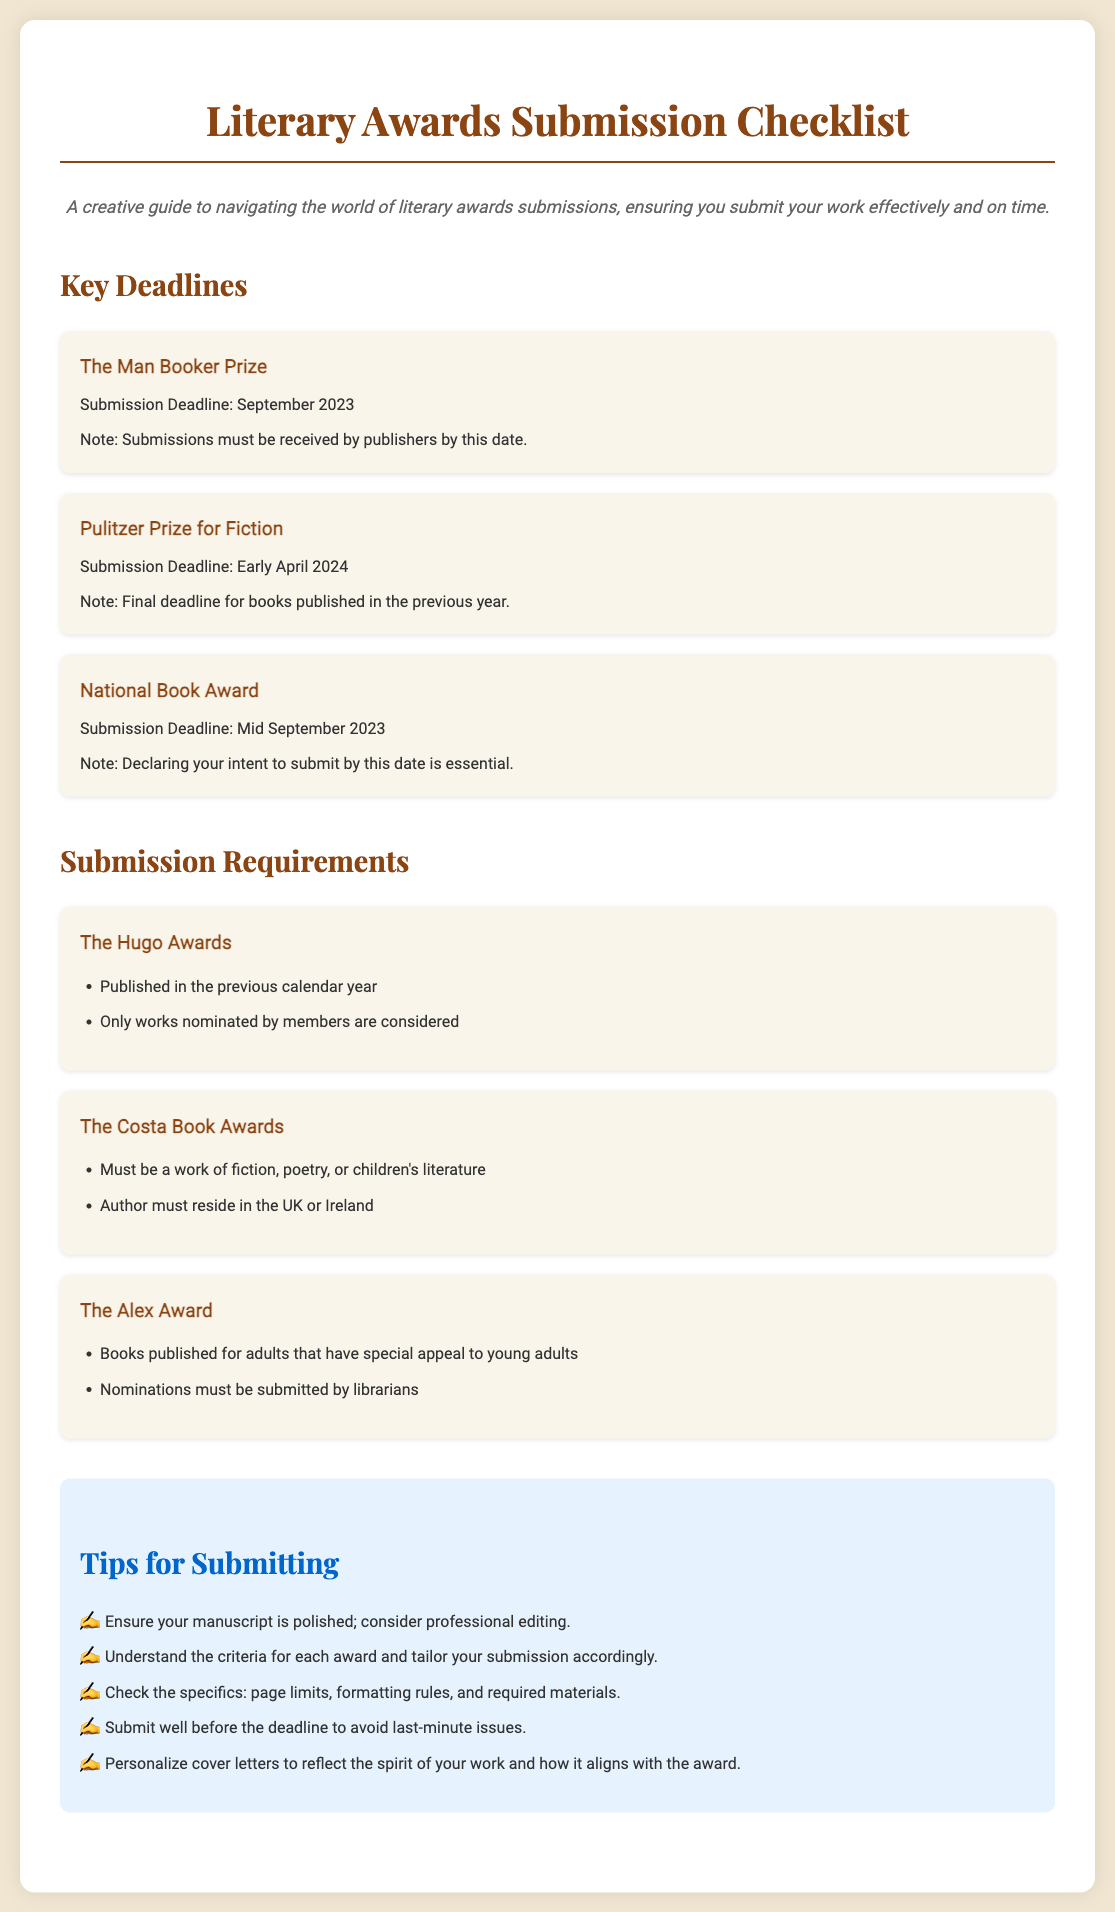What is the submission deadline for The Man Booker Prize? The document specifies that the submission deadline for The Man Booker Prize is September 2023.
Answer: September 2023 What is one requirement for The Hugo Awards? According to the document, one of the requirements for The Hugo Awards is that the work must be published in the previous calendar year.
Answer: Published in the previous calendar year What must authors do for the National Book Award by mid-September 2023? The document states that declaring your intent to submit by mid-September 2023 is essential for the National Book Award.
Answer: Declare intent to submit Who can nominate works for The Alex Award? The document indicates that nominations for The Alex Award must be submitted by librarians.
Answer: Librarians What should you check before submitting for any award? The document emphasizes the importance of checking specifics like page limits, formatting rules, and required materials before submitting for any award.
Answer: Page limits, formatting rules, required materials What is a tip for submitting manuscripts? One of the tips provided in the document is to ensure your manuscript is polished and to consider professional editing.
Answer: Ensure your manuscript is polished What type of literature is eligible for The Costa Book Awards? The document states that The Costa Book Awards must be a work of fiction, poetry, or children's literature.
Answer: Fiction, poetry, or children's literature What is the deadline for the Pulitzer Prize for Fiction? The document notes that the submission deadline for the Pulitzer Prize for Fiction is early April 2024.
Answer: Early April 2024 